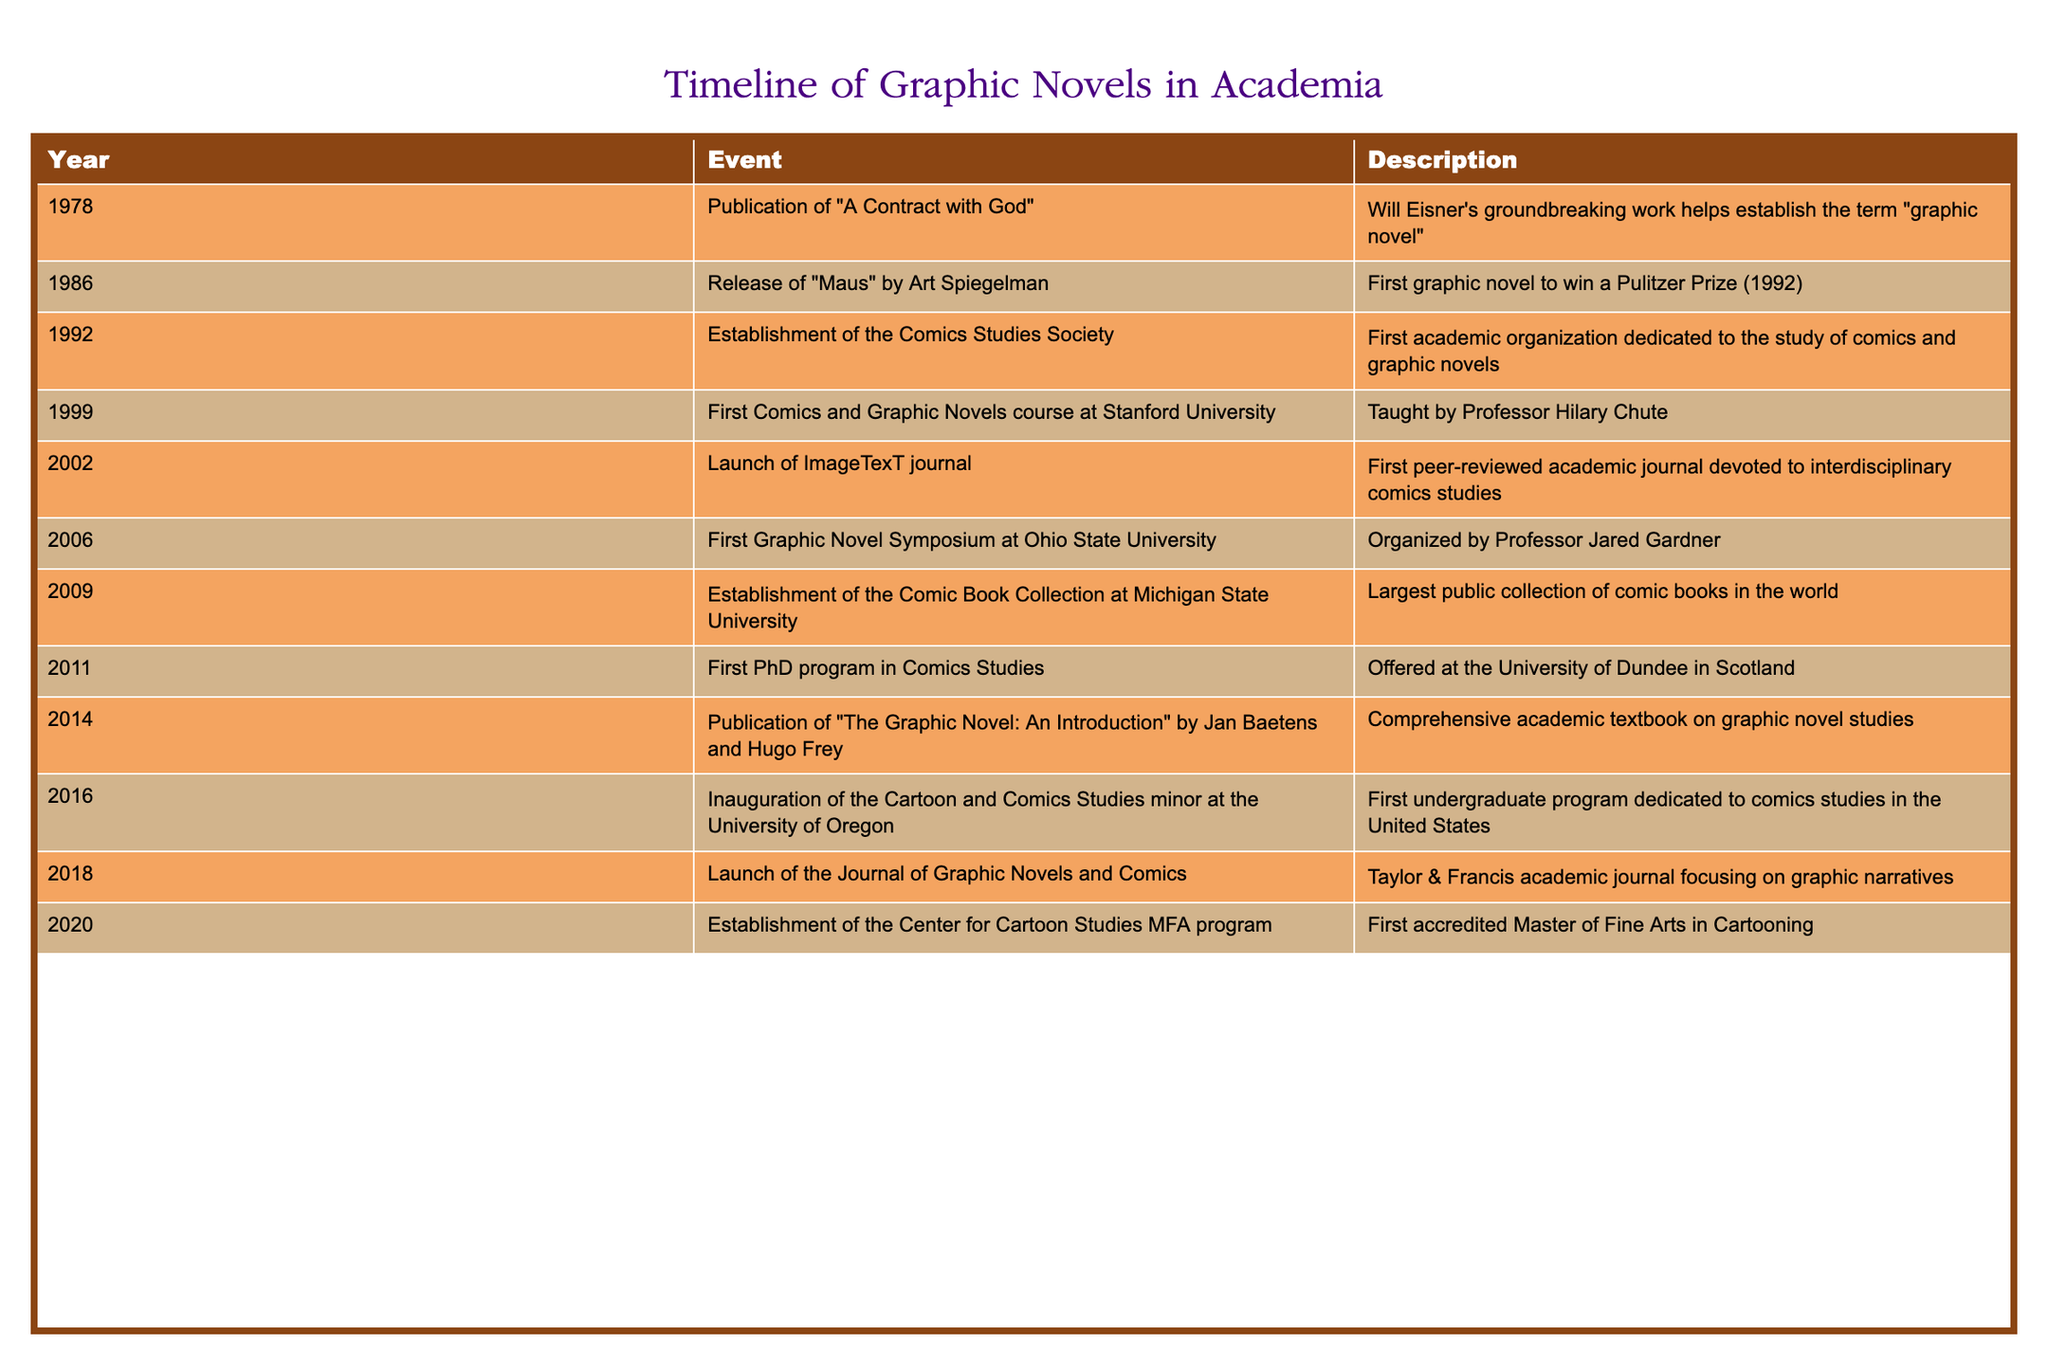What year was "A Contract with God" published? The table indicates that "A Contract with God" was published in 1978.
Answer: 1978 What significant event occurred in 1992 related to comics studies? The table shows that the Comics Studies Society was established in 1992, marking the formation of the first academic organization devoted to this field.
Answer: Establishment of the Comics Studies Society Did any graphic novel win a Pulitzer Prize, and if so, who created it? Yes, the graphic novel "Maus," created by Art Spiegelman, won a Pulitzer Prize. The table lists this milestone under the year 1986.
Answer: Yes, "Maus" by Art Spiegelman How many years passed between the release of "Maus" and the establishment of the Comics Studies Society? The table shows that "Maus" was released in 1986 and the Comics Studies Society was established in 1992. The difference is 1992 - 1986 = 6 years.
Answer: 6 years What is the significance of the launch of ImageTexT journal in 2002? According to the table, the launch of ImageTexT in 2002 is noted as the first peer-reviewed academic journal devoted to interdisciplinary comics studies, which indicates a growth in academic recognition of graphic novels.
Answer: First peer-reviewed journal for comics studies In which year did the University of Oregon inaugurate the Cartoon and Comics Studies minor? The table indicates that the University of Oregon inaugurated this minor in 2016.
Answer: 2016 Which milestone marked the first PhD program in Comics Studies? The establishment of the first PhD program in Comics Studies occurred in 2011 at the University of Dundee in Scotland, according to the data in the table.
Answer: 2011 How many institutions have established programs specifically dedicated to comics studies by 2020? Reviewing the table, we see that there are three notable academic programs with the Comics Studies Society (1992), the Cartoon and Comics Studies minor (2016), and the Center for Cartoon Studies MFA program (2020), totaling three.
Answer: 3 institutions Was the launch of the Journal of Graphic Novels and Comics significant in 2018? Yes, the launch of this journal in 2018 is listed in the table as an important event focused on graphic narratives, further indicating academic recognition of the field.
Answer: Yes 